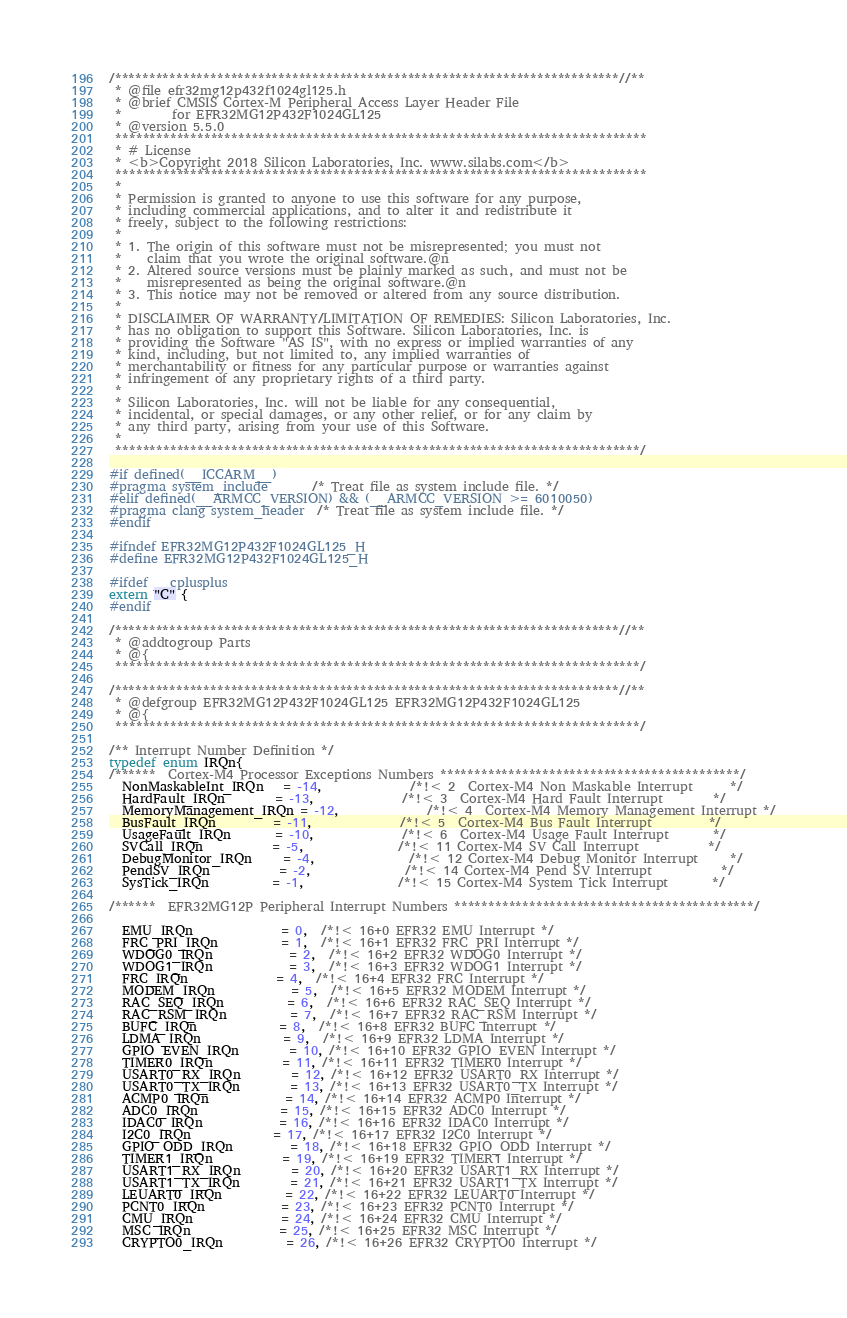Convert code to text. <code><loc_0><loc_0><loc_500><loc_500><_C_>/**************************************************************************//**
 * @file efr32mg12p432f1024gl125.h
 * @brief CMSIS Cortex-M Peripheral Access Layer Header File
 *        for EFR32MG12P432F1024GL125
 * @version 5.5.0
 ******************************************************************************
 * # License
 * <b>Copyright 2018 Silicon Laboratories, Inc. www.silabs.com</b>
 ******************************************************************************
 *
 * Permission is granted to anyone to use this software for any purpose,
 * including commercial applications, and to alter it and redistribute it
 * freely, subject to the following restrictions:
 *
 * 1. The origin of this software must not be misrepresented; you must not
 *    claim that you wrote the original software.@n
 * 2. Altered source versions must be plainly marked as such, and must not be
 *    misrepresented as being the original software.@n
 * 3. This notice may not be removed or altered from any source distribution.
 *
 * DISCLAIMER OF WARRANTY/LIMITATION OF REMEDIES: Silicon Laboratories, Inc.
 * has no obligation to support this Software. Silicon Laboratories, Inc. is
 * providing the Software "AS IS", with no express or implied warranties of any
 * kind, including, but not limited to, any implied warranties of
 * merchantability or fitness for any particular purpose or warranties against
 * infringement of any proprietary rights of a third party.
 *
 * Silicon Laboratories, Inc. will not be liable for any consequential,
 * incidental, or special damages, or any other relief, or for any claim by
 * any third party, arising from your use of this Software.
 *
 *****************************************************************************/

#if defined(__ICCARM__)
#pragma system_include       /* Treat file as system include file. */
#elif defined(__ARMCC_VERSION) && (__ARMCC_VERSION >= 6010050)
#pragma clang system_header  /* Treat file as system include file. */
#endif

#ifndef EFR32MG12P432F1024GL125_H
#define EFR32MG12P432F1024GL125_H

#ifdef __cplusplus
extern "C" {
#endif

/**************************************************************************//**
 * @addtogroup Parts
 * @{
 *****************************************************************************/

/**************************************************************************//**
 * @defgroup EFR32MG12P432F1024GL125 EFR32MG12P432F1024GL125
 * @{
 *****************************************************************************/

/** Interrupt Number Definition */
typedef enum IRQn{
/******  Cortex-M4 Processor Exceptions Numbers ********************************************/
  NonMaskableInt_IRQn   = -14,              /*!< 2  Cortex-M4 Non Maskable Interrupt      */
  HardFault_IRQn        = -13,              /*!< 3  Cortex-M4 Hard Fault Interrupt        */
  MemoryManagement_IRQn = -12,              /*!< 4  Cortex-M4 Memory Management Interrupt */
  BusFault_IRQn         = -11,              /*!< 5  Cortex-M4 Bus Fault Interrupt         */
  UsageFault_IRQn       = -10,              /*!< 6  Cortex-M4 Usage Fault Interrupt       */
  SVCall_IRQn           = -5,               /*!< 11 Cortex-M4 SV Call Interrupt           */
  DebugMonitor_IRQn     = -4,               /*!< 12 Cortex-M4 Debug Monitor Interrupt     */
  PendSV_IRQn           = -2,               /*!< 14 Cortex-M4 Pend SV Interrupt           */
  SysTick_IRQn          = -1,               /*!< 15 Cortex-M4 System Tick Interrupt       */

/******  EFR32MG12P Peripheral Interrupt Numbers ********************************************/

  EMU_IRQn              = 0,  /*!< 16+0 EFR32 EMU Interrupt */
  FRC_PRI_IRQn          = 1,  /*!< 16+1 EFR32 FRC_PRI Interrupt */
  WDOG0_IRQn            = 2,  /*!< 16+2 EFR32 WDOG0 Interrupt */
  WDOG1_IRQn            = 3,  /*!< 16+3 EFR32 WDOG1 Interrupt */
  FRC_IRQn              = 4,  /*!< 16+4 EFR32 FRC Interrupt */
  MODEM_IRQn            = 5,  /*!< 16+5 EFR32 MODEM Interrupt */
  RAC_SEQ_IRQn          = 6,  /*!< 16+6 EFR32 RAC_SEQ Interrupt */
  RAC_RSM_IRQn          = 7,  /*!< 16+7 EFR32 RAC_RSM Interrupt */
  BUFC_IRQn             = 8,  /*!< 16+8 EFR32 BUFC Interrupt */
  LDMA_IRQn             = 9,  /*!< 16+9 EFR32 LDMA Interrupt */
  GPIO_EVEN_IRQn        = 10, /*!< 16+10 EFR32 GPIO_EVEN Interrupt */
  TIMER0_IRQn           = 11, /*!< 16+11 EFR32 TIMER0 Interrupt */
  USART0_RX_IRQn        = 12, /*!< 16+12 EFR32 USART0_RX Interrupt */
  USART0_TX_IRQn        = 13, /*!< 16+13 EFR32 USART0_TX Interrupt */
  ACMP0_IRQn            = 14, /*!< 16+14 EFR32 ACMP0 Interrupt */
  ADC0_IRQn             = 15, /*!< 16+15 EFR32 ADC0 Interrupt */
  IDAC0_IRQn            = 16, /*!< 16+16 EFR32 IDAC0 Interrupt */
  I2C0_IRQn             = 17, /*!< 16+17 EFR32 I2C0 Interrupt */
  GPIO_ODD_IRQn         = 18, /*!< 16+18 EFR32 GPIO_ODD Interrupt */
  TIMER1_IRQn           = 19, /*!< 16+19 EFR32 TIMER1 Interrupt */
  USART1_RX_IRQn        = 20, /*!< 16+20 EFR32 USART1_RX Interrupt */
  USART1_TX_IRQn        = 21, /*!< 16+21 EFR32 USART1_TX Interrupt */
  LEUART0_IRQn          = 22, /*!< 16+22 EFR32 LEUART0 Interrupt */
  PCNT0_IRQn            = 23, /*!< 16+23 EFR32 PCNT0 Interrupt */
  CMU_IRQn              = 24, /*!< 16+24 EFR32 CMU Interrupt */
  MSC_IRQn              = 25, /*!< 16+25 EFR32 MSC Interrupt */
  CRYPTO0_IRQn          = 26, /*!< 16+26 EFR32 CRYPTO0 Interrupt */</code> 